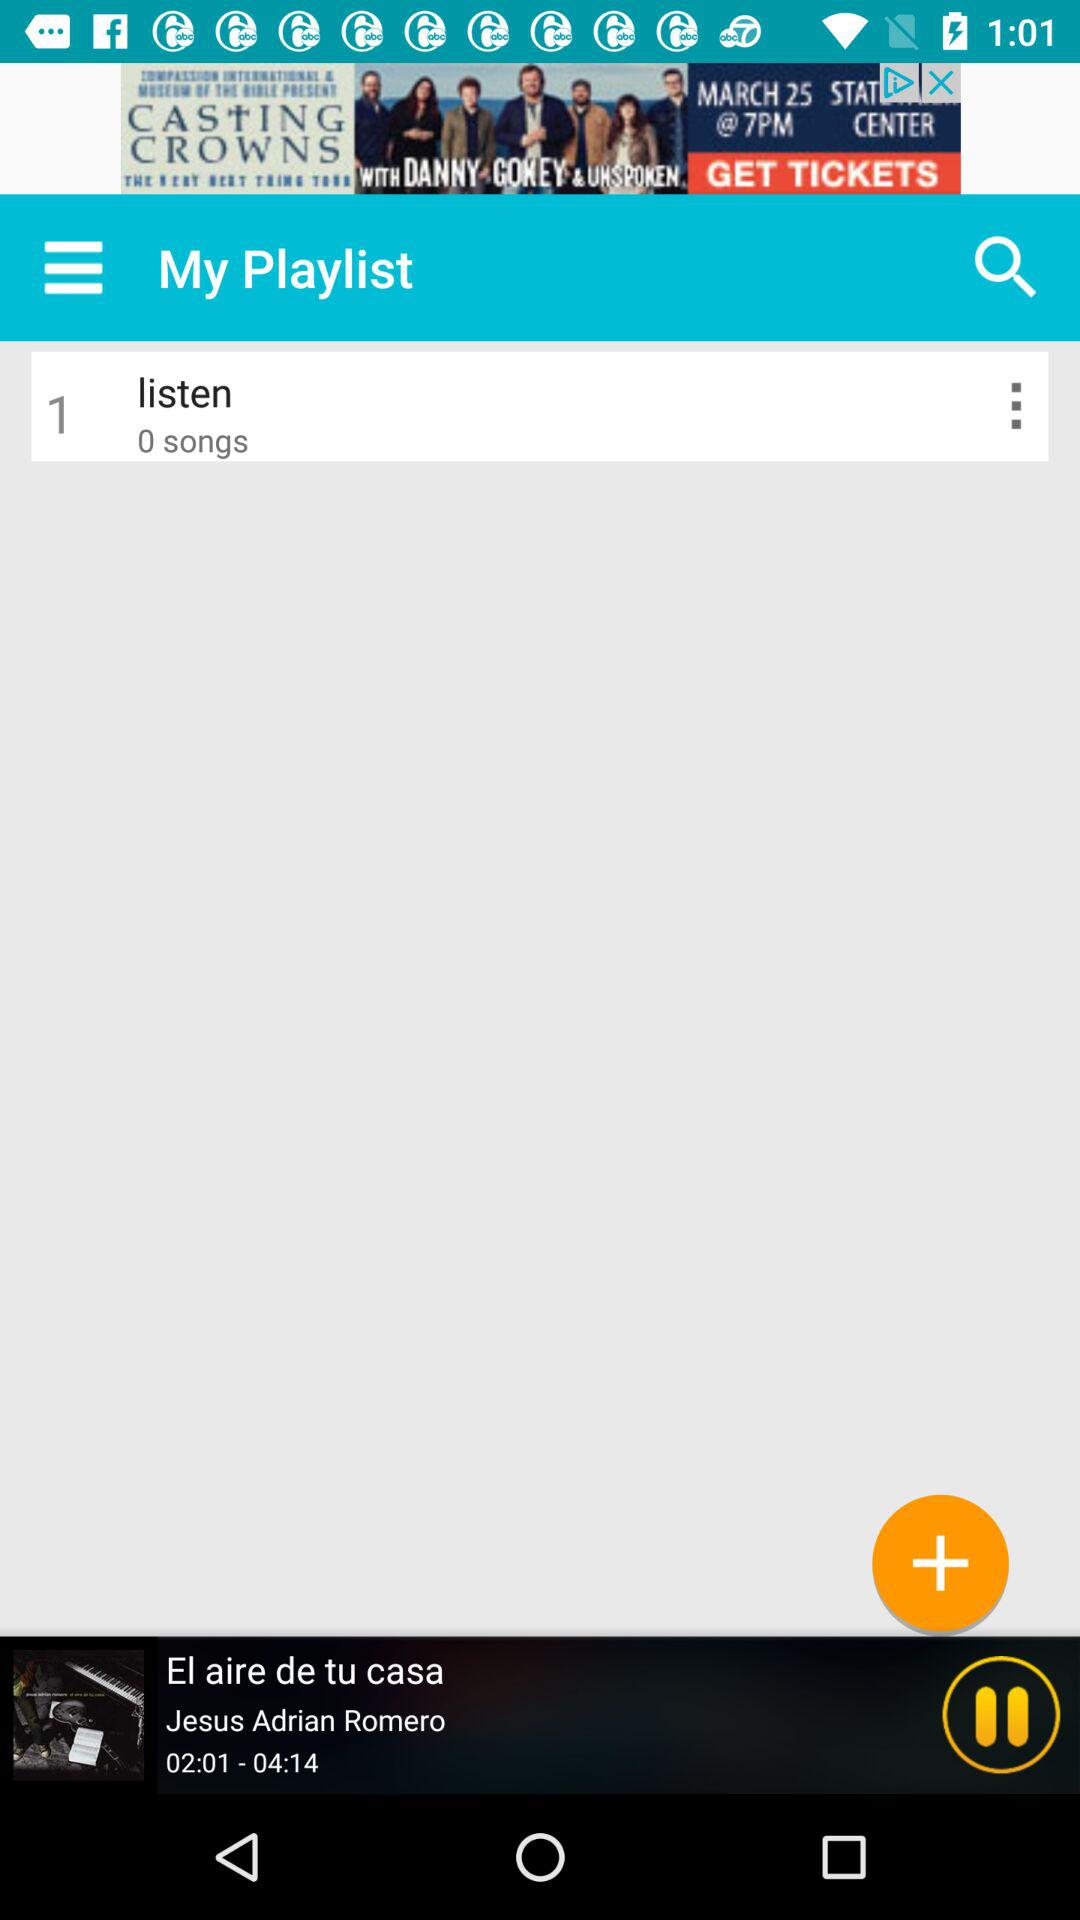How many songs are added to the listen list? There are 0 songs added to the listen list. 